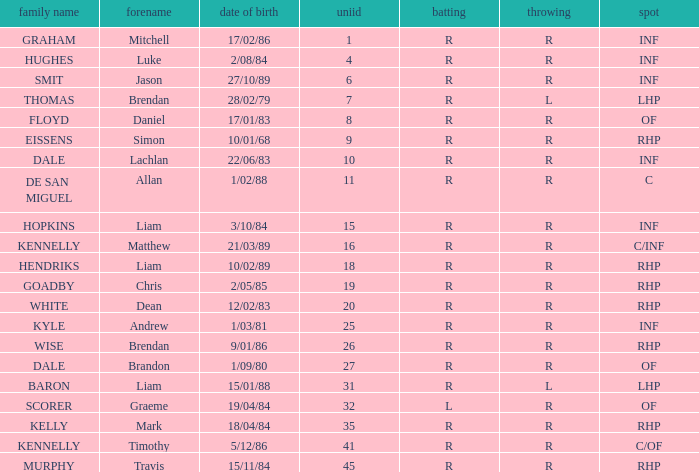Which batter has a uni# of 31? R. 